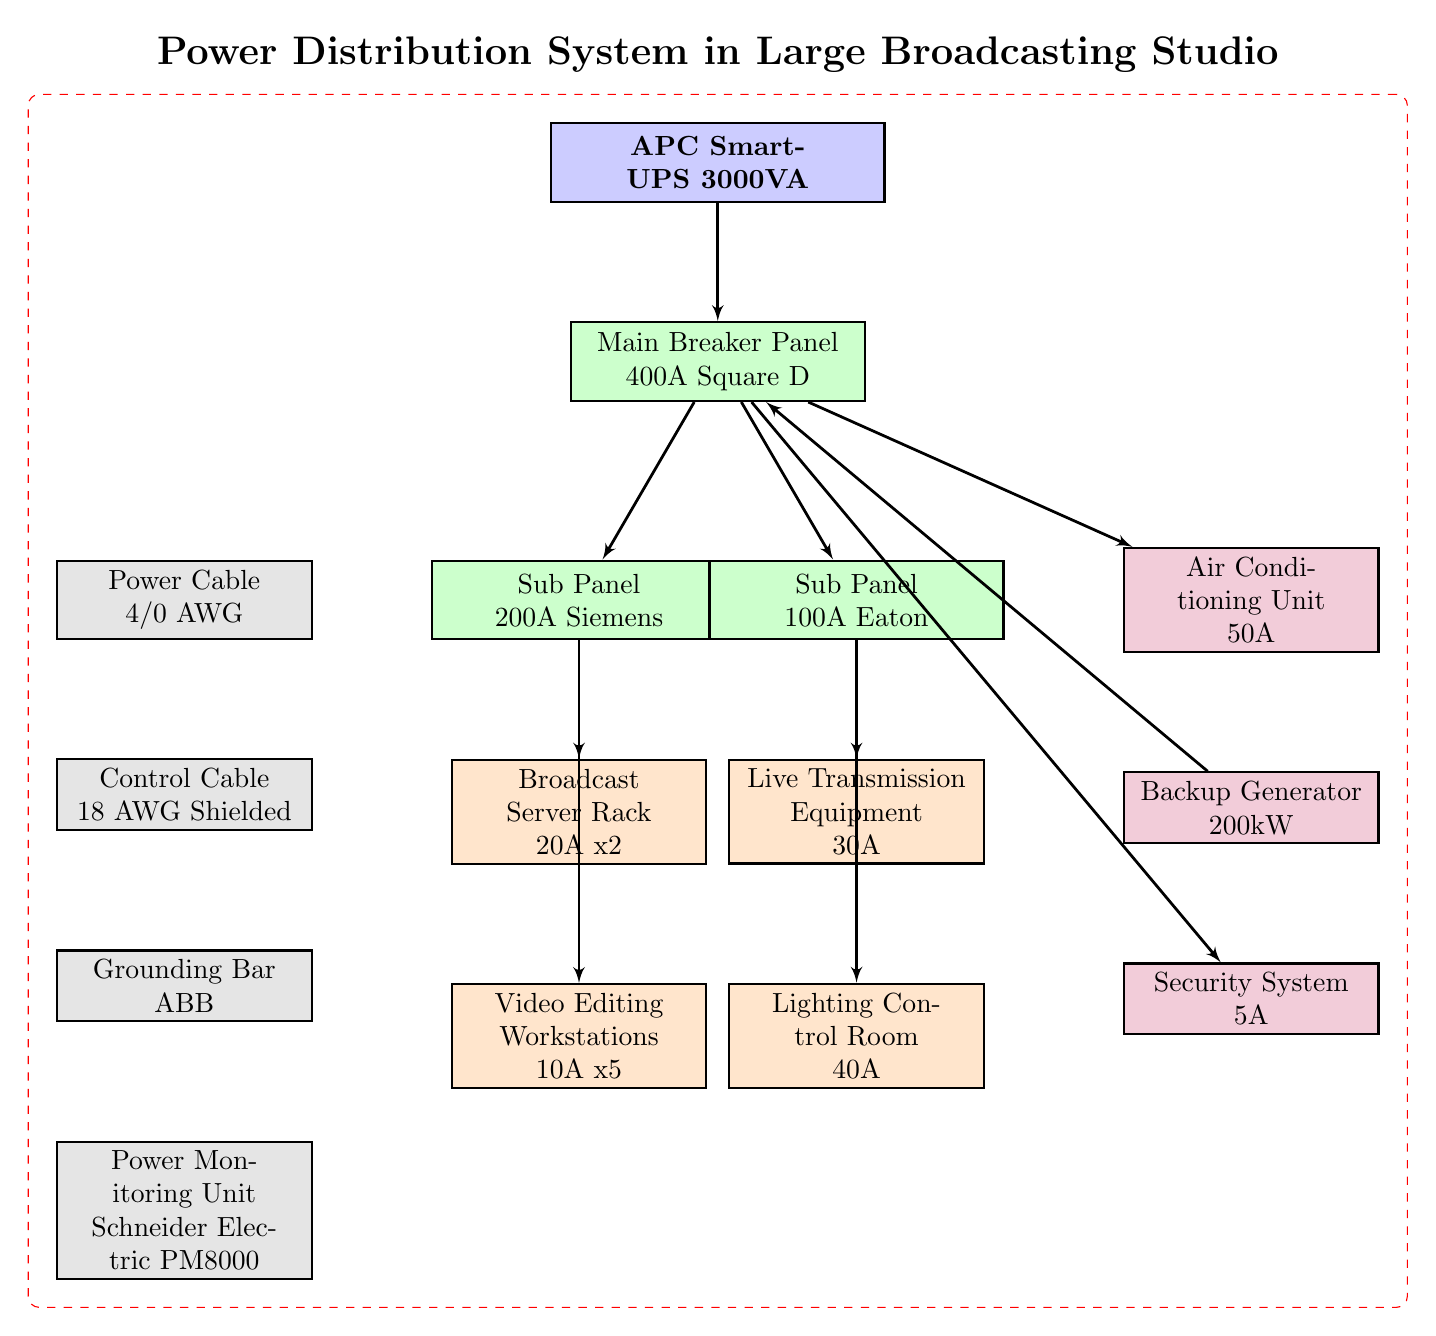What is the total amperage supported by the Broadcast Server Rack? The Broadcast Server Rack has 20A x 2, which means it can handle a maximum of 40A of current.
Answer: 40A Which component connects directly to the Main Breaker Panel? The components that connect directly to the Main Breaker Panel include the Sub Panels (200A Siemens and 100A Eaton), Air Conditioning Unit, and Security System.
Answer: Sub Panels, Air Conditioning Unit, Security System How many Video Editing Workstations are shown in the diagram? The diagram shows five Video Editing Workstations, which is indicated by the labeling of the equipment node.
Answer: 5 What type of power supply is used in the system? The power supply indicated in the diagram is an APC Smart-UPS 3000VA, as labeled at the top of the structure.
Answer: APC Smart-UPS 3000VA What is the maximum capacity of the Backup Generator? The Backup Generator is indicated as having a capacity of 200kW, which directly reflects the information shown in the auxiliary equipment node.
Answer: 200kW Which two components receive power from the Sub Panel with 200A? The Sub Panel with 200A connects to the Broadcast Server Rack and the Video Editing Workstations, as shown in the connections from this node.
Answer: Broadcast Server Rack, Video Editing Workstations What is the amperage rating of the Live Transmission Equipment? The Live Transmission Equipment is specified as requiring 30A of current in the diagram, clearly marked below its title.
Answer: 30A Which equipment utilizes the most power from the indicated components? The Lighting Control Room uses 40A, which is the highest amperage compared to other pieces of equipment in the system, as detailed in the diagram.
Answer: Lighting Control Room What type of cable is used for power distribution in the system? The diagram indicates the use of a Power Cable rated at 4/0 AWG, which is specified in the miscellaneous section of the diagram.
Answer: Power Cable 4/0 AWG 